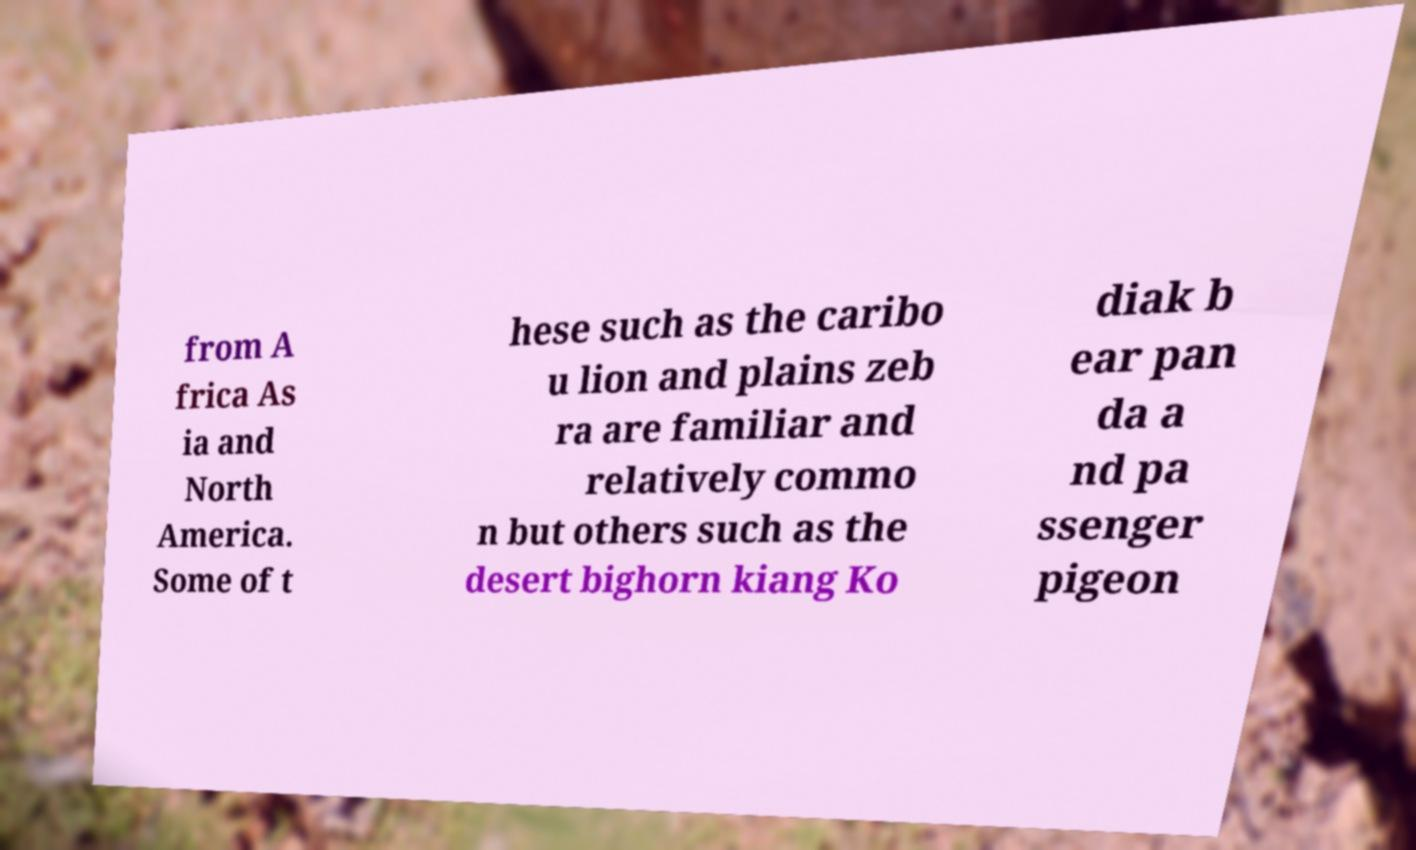What messages or text are displayed in this image? I need them in a readable, typed format. from A frica As ia and North America. Some of t hese such as the caribo u lion and plains zeb ra are familiar and relatively commo n but others such as the desert bighorn kiang Ko diak b ear pan da a nd pa ssenger pigeon 